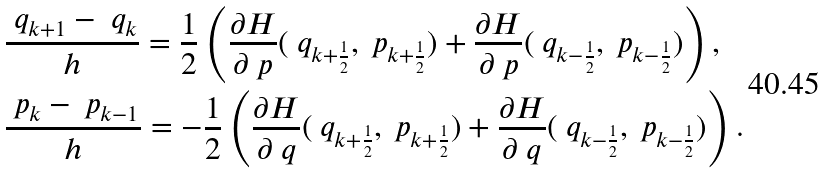Convert formula to latex. <formula><loc_0><loc_0><loc_500><loc_500>& \frac { \ q _ { k + 1 } - \ q _ { k } } { h } = \frac { 1 } { 2 } \left ( \frac { \partial H } { \partial \ p } ( \ q _ { k + \frac { 1 } { 2 } } , \ p _ { k + \frac { 1 } { 2 } } ) + \frac { \partial H } { \partial \ p } ( \ q _ { k - \frac { 1 } { 2 } } , \ p _ { k - \frac { 1 } { 2 } } ) \right ) , \\ & \frac { \ p _ { k } - \ p _ { k - 1 } } { h } = - \frac { 1 } { 2 } \left ( \frac { \partial H } { \partial \ q } ( \ q _ { k + \frac { 1 } { 2 } } , \ p _ { k + \frac { 1 } { 2 } } ) + \frac { \partial H } { \partial \ q } ( \ q _ { k - \frac { 1 } { 2 } } , \ p _ { k - \frac { 1 } { 2 } } ) \right ) .</formula> 